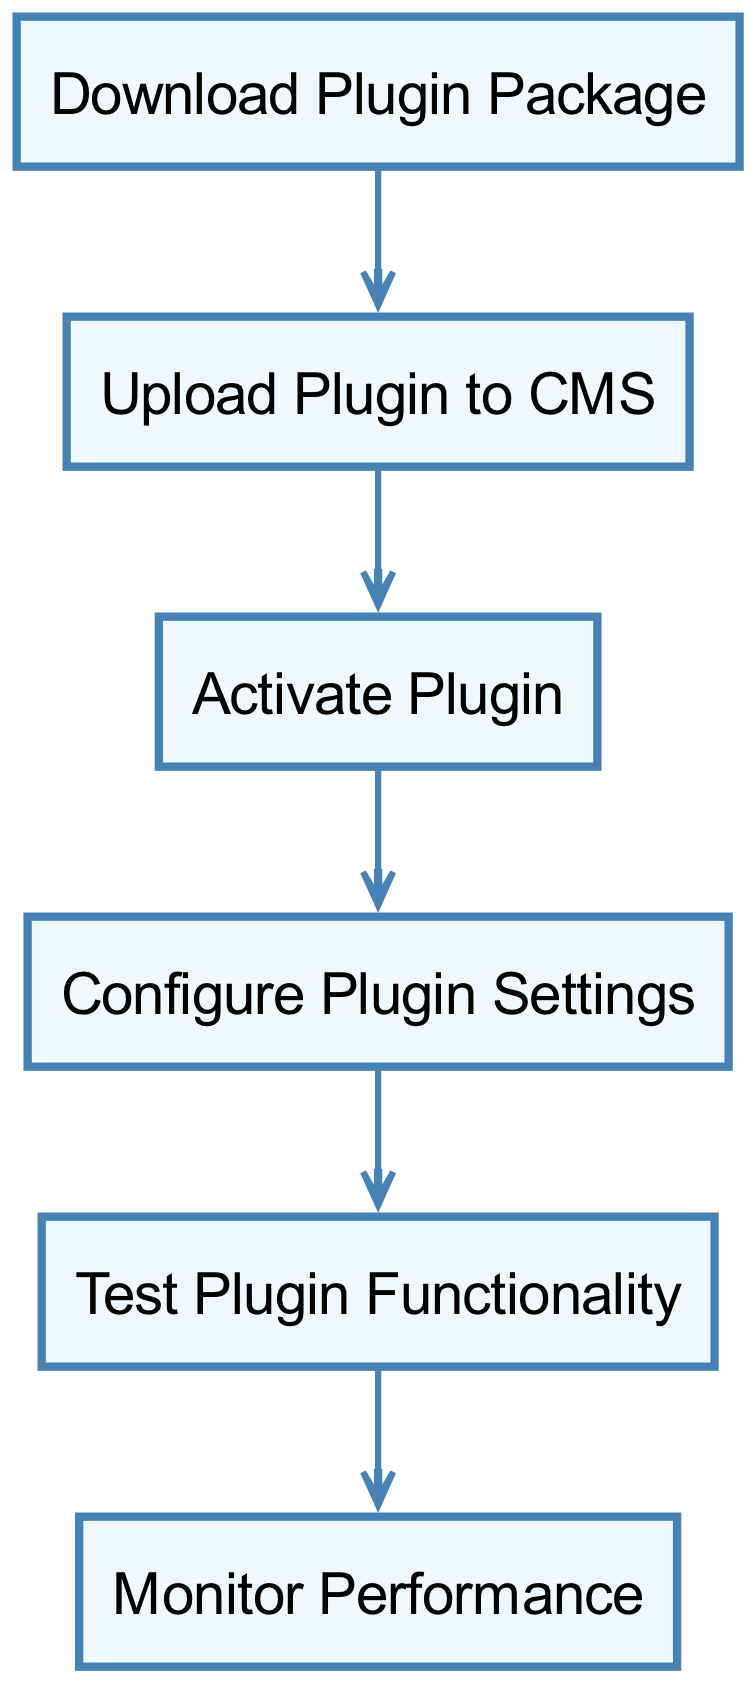What is the first step in the plugin installation process? The diagram clearly indicates that the first node in the directed graph is labeled "Download Plugin Package." This node represents the initial step that must be taken.
Answer: Download Plugin Package How many total nodes are represented in the diagram? By counting all the unique steps listed within the graph, there are six nodes present: Download Plugin Package, Upload Plugin to CMS, Activate Plugin, Configure Plugin Settings, Test Plugin Functionality, and Monitor Performance.
Answer: 6 Which step comes immediately after activating the plugin? The directed graph shows a direct connection from the "Activate Plugin" node to the "Configure Plugin Settings" node, indicating that configuration happens immediately after activation.
Answer: Configure Plugin Settings What is the last step in the installation process? Following the flow of the directed graph from the starting node to the end, the final node labeled is "Monitor Performance," which represents the last action to be taken after testing functionality.
Answer: Monitor Performance Which two steps are directly connected by an edge besides the first step? The edges represent direct connections between subsequent steps. "Upload Plugin to CMS" is connected to "Activate Plugin," and "Activate Plugin" is connected to "Configure Plugin Settings." Thus, both connections are valid answers.
Answer: Upload Plugin to CMS, Activate Plugin What step involves checking the functionality of the plugin? The node distinctly labeled "Test Plugin Functionality" describes the specific action of testing how well the plugin operates once it is configured.
Answer: Test Plugin Functionality How many edges are in the diagram? Each connection from one node to another represents an edge. In the diagram, there are five edges connecting the six steps outlined, showing the progression through the installation process.
Answer: 5 What is the relationship between "Download Plugin Package" and "Upload Plugin to CMS"? The directed graph depicts a direct progression from "Download Plugin Package" to "Upload Plugin to CMS," indicating that the first step must be completed before the second step can occur.
Answer: Sequential relationship 